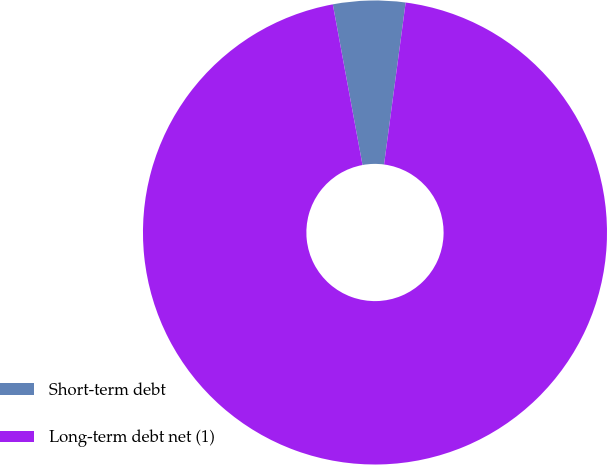<chart> <loc_0><loc_0><loc_500><loc_500><pie_chart><fcel>Short-term debt<fcel>Long-term debt net (1)<nl><fcel>5.02%<fcel>94.98%<nl></chart> 